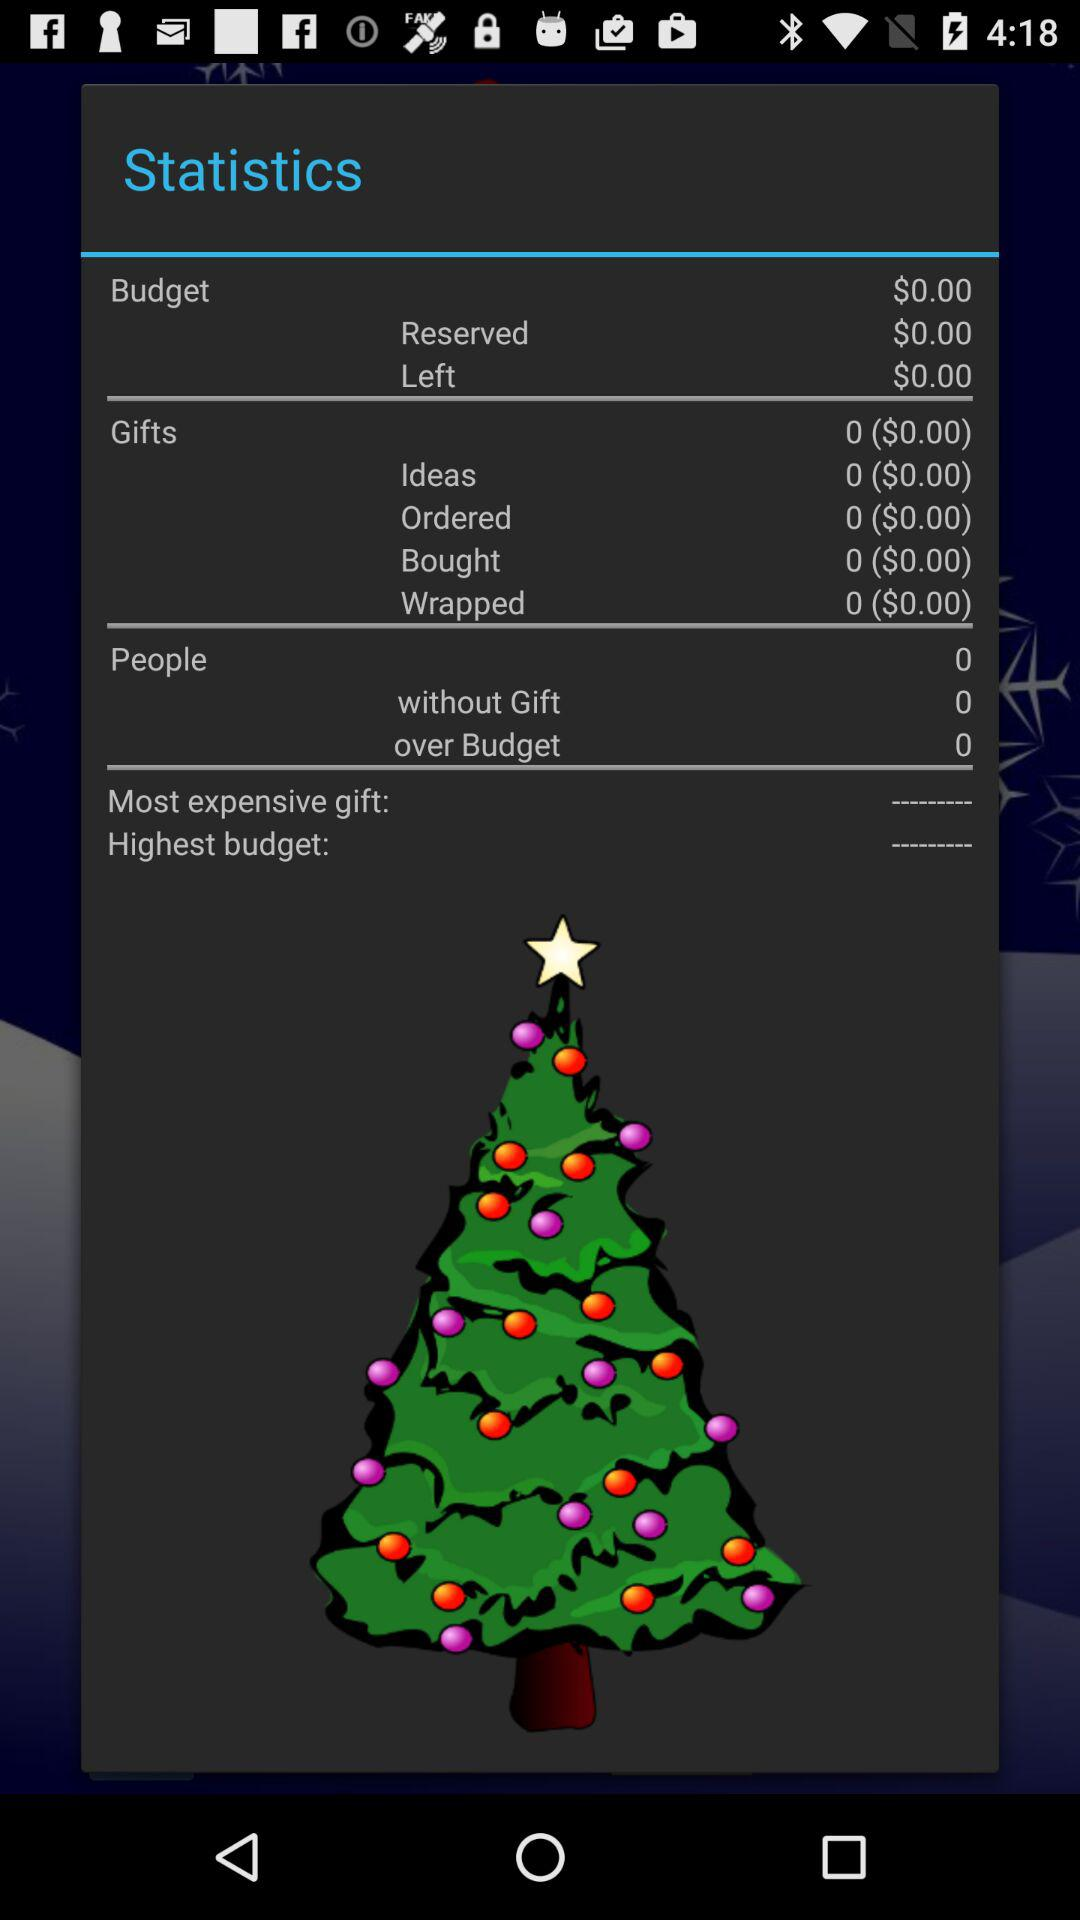How many bought gifts for people are there? There are 0 bought gifts. 